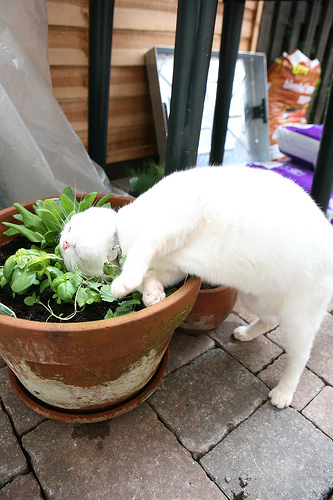Can you describe the scene where the cat is? Certainly! The scene shows a white cat leaning into a pot that contains a green plant. The pot is placed on a sidewalk made of stone tiles. In the background, there are various items, including a silver tray, a bag, and an orange object. The setting appears to be an outdoor area, possibly a garden or a patio. 